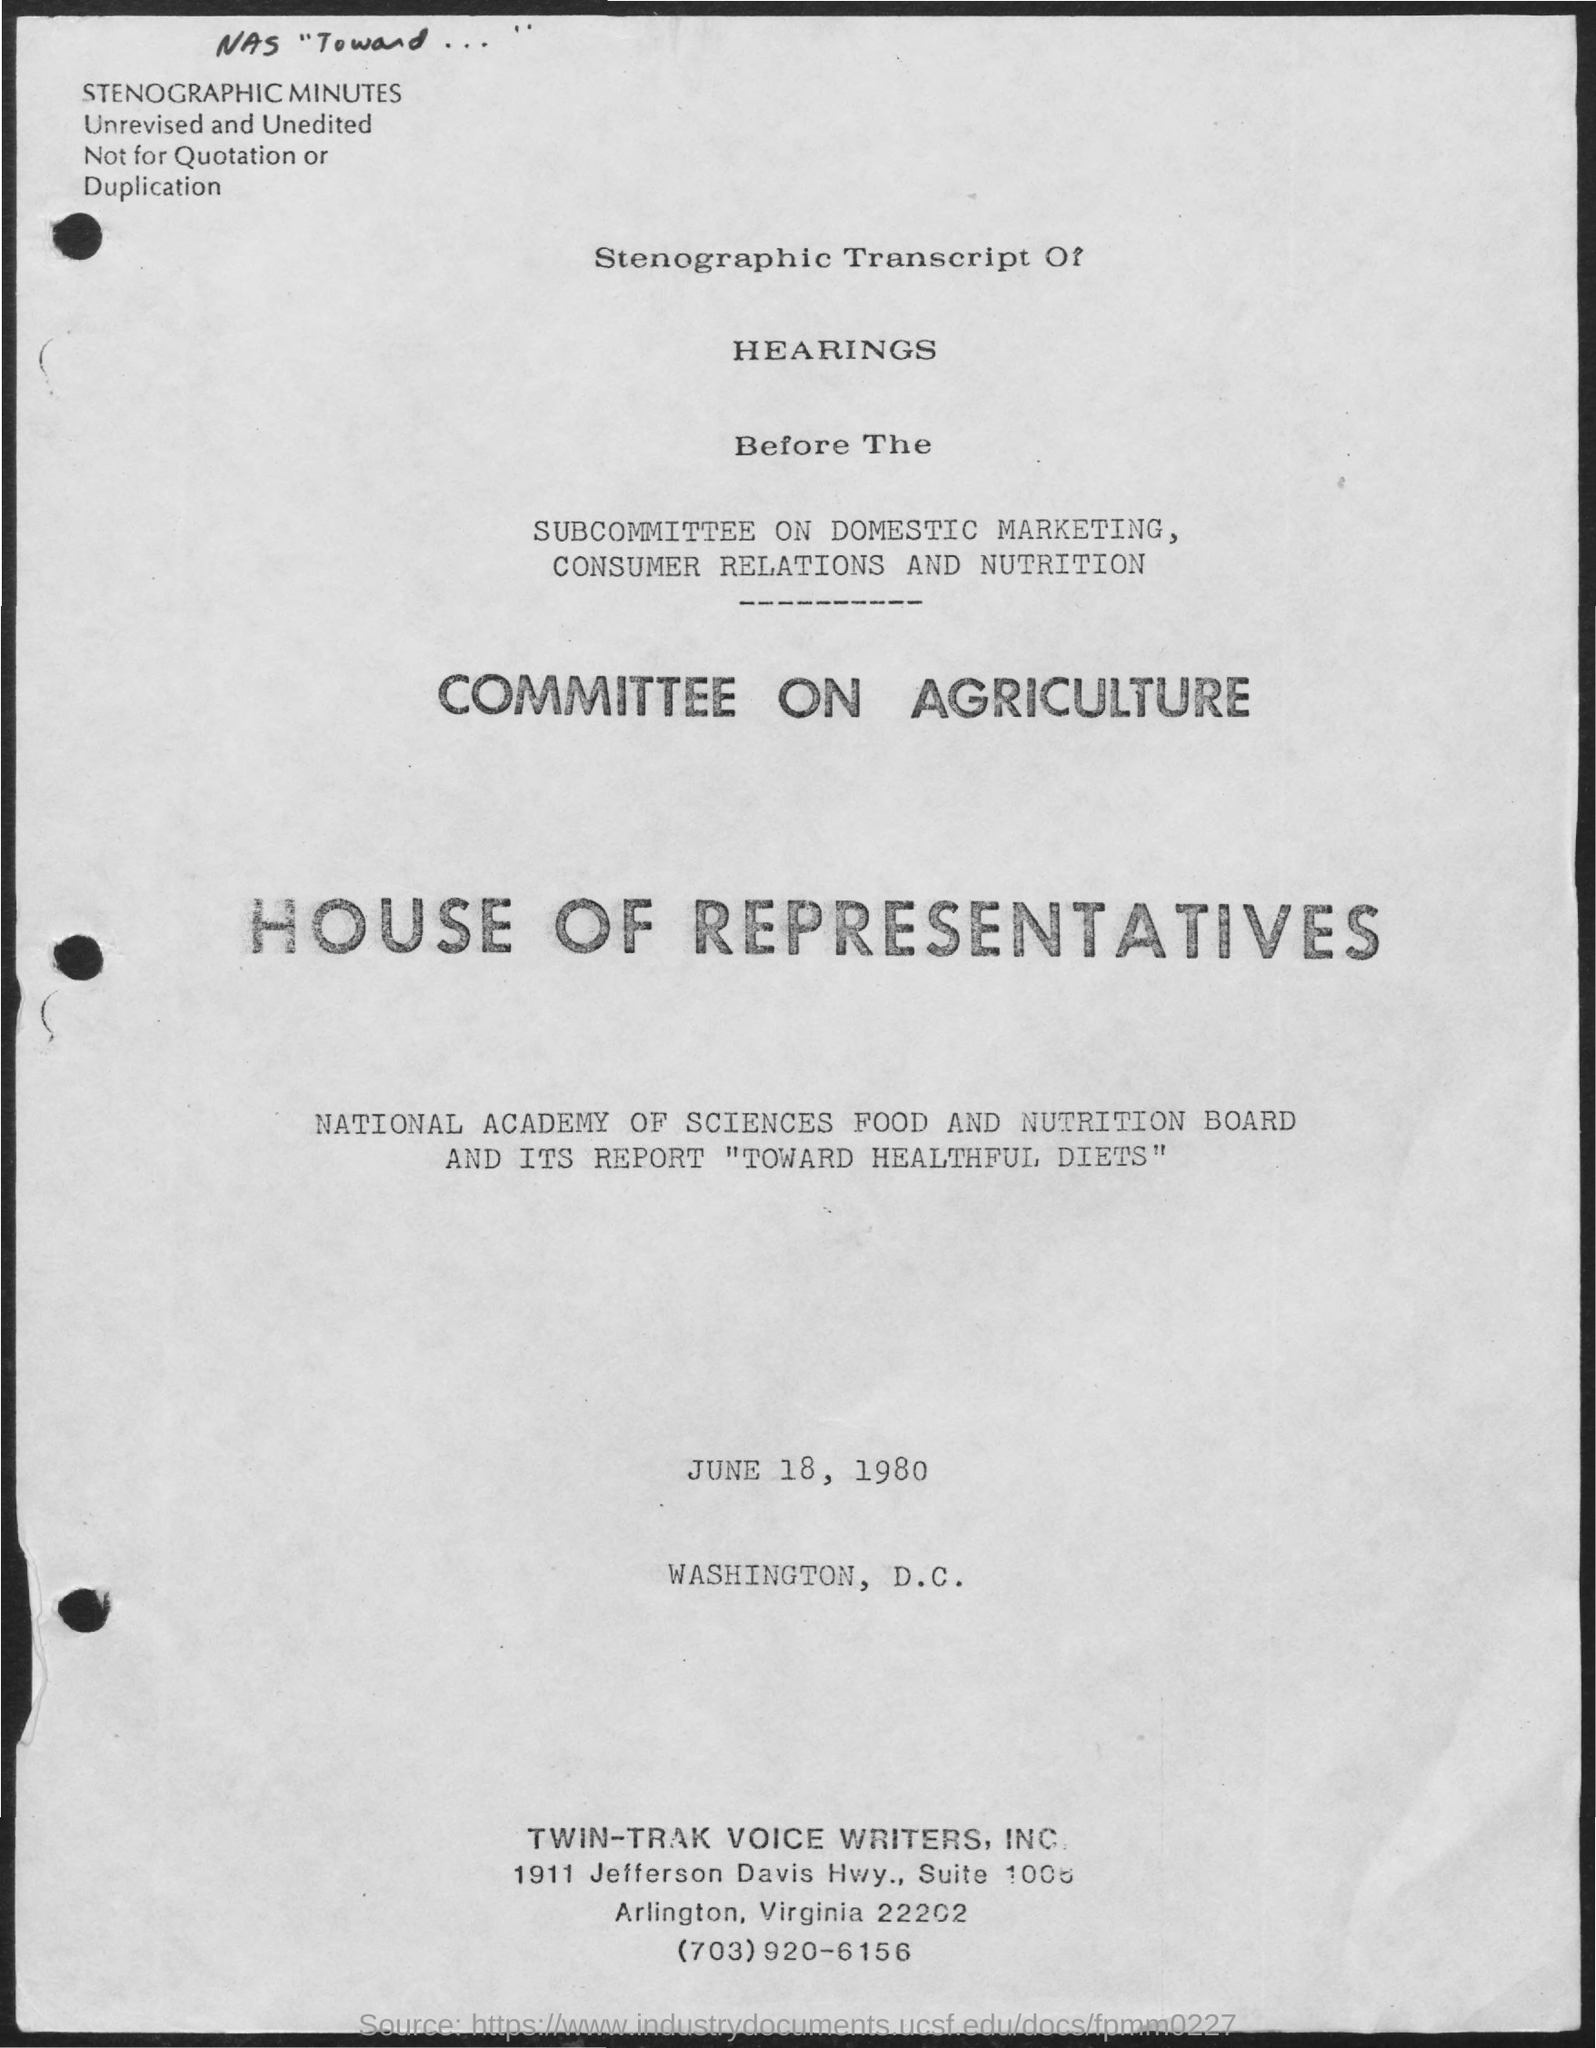What is the date mentioned in the given page ?
Your response must be concise. June 18, 1980. What is the committee based on ?
Offer a terse response. Committee on agriculture. 